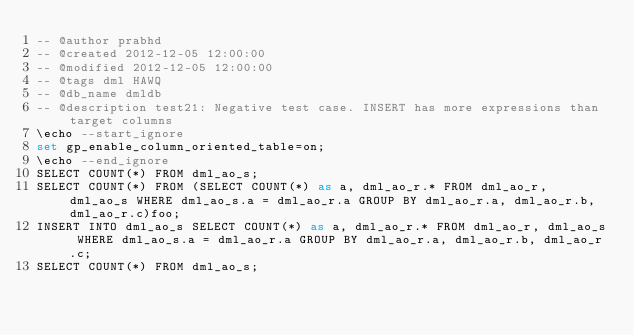Convert code to text. <code><loc_0><loc_0><loc_500><loc_500><_SQL_>-- @author prabhd 
-- @created 2012-12-05 12:00:00 
-- @modified 2012-12-05 12:00:00 
-- @tags dml HAWQ 
-- @db_name dmldb
-- @description test21: Negative test case. INSERT has more expressions than target columns
\echo --start_ignore
set gp_enable_column_oriented_table=on;
\echo --end_ignore
SELECT COUNT(*) FROM dml_ao_s;
SELECT COUNT(*) FROM (SELECT COUNT(*) as a, dml_ao_r.* FROM dml_ao_r, dml_ao_s WHERE dml_ao_s.a = dml_ao_r.a GROUP BY dml_ao_r.a, dml_ao_r.b, dml_ao_r.c)foo;
INSERT INTO dml_ao_s SELECT COUNT(*) as a, dml_ao_r.* FROM dml_ao_r, dml_ao_s WHERE dml_ao_s.a = dml_ao_r.a GROUP BY dml_ao_r.a, dml_ao_r.b, dml_ao_r.c;
SELECT COUNT(*) FROM dml_ao_s;
</code> 